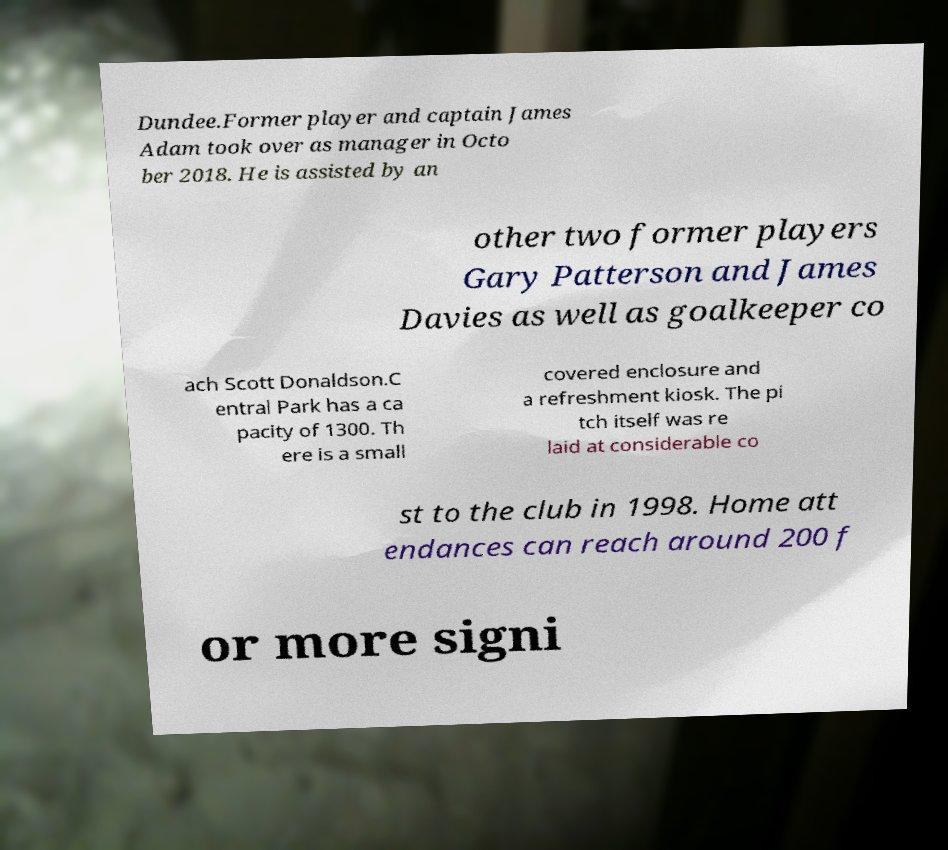There's text embedded in this image that I need extracted. Can you transcribe it verbatim? Dundee.Former player and captain James Adam took over as manager in Octo ber 2018. He is assisted by an other two former players Gary Patterson and James Davies as well as goalkeeper co ach Scott Donaldson.C entral Park has a ca pacity of 1300. Th ere is a small covered enclosure and a refreshment kiosk. The pi tch itself was re laid at considerable co st to the club in 1998. Home att endances can reach around 200 f or more signi 